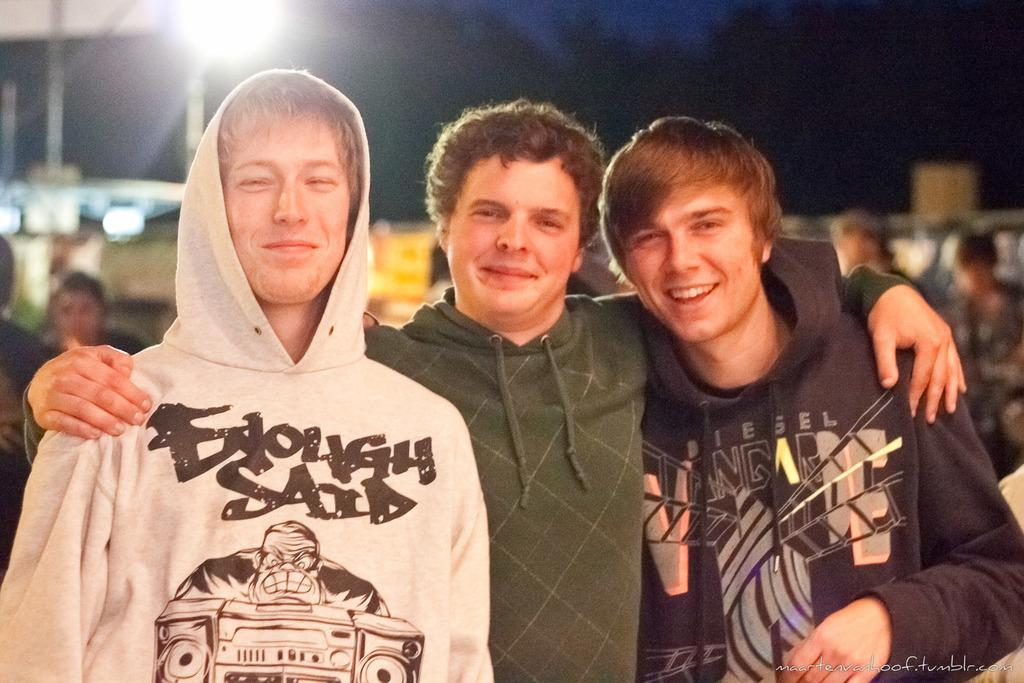How many people are in the image? There are three people in the image. What are the people doing in the image? The people are looking at something and smiling. What are the people wearing in the image? The people are wearing hoodies. Can you describe the background of the image? The background of the image has a blurred view, and there are other people visible in the background. Is there any source of light in the image? Yes, there is light in the image. What type of magic trick are the people performing in the image? There is no magic trick being performed in the image; the people are simply looking at something and smiling. How many rings can be seen on the people's fingers in the image? There are no rings visible on the people's fingers in the image. 